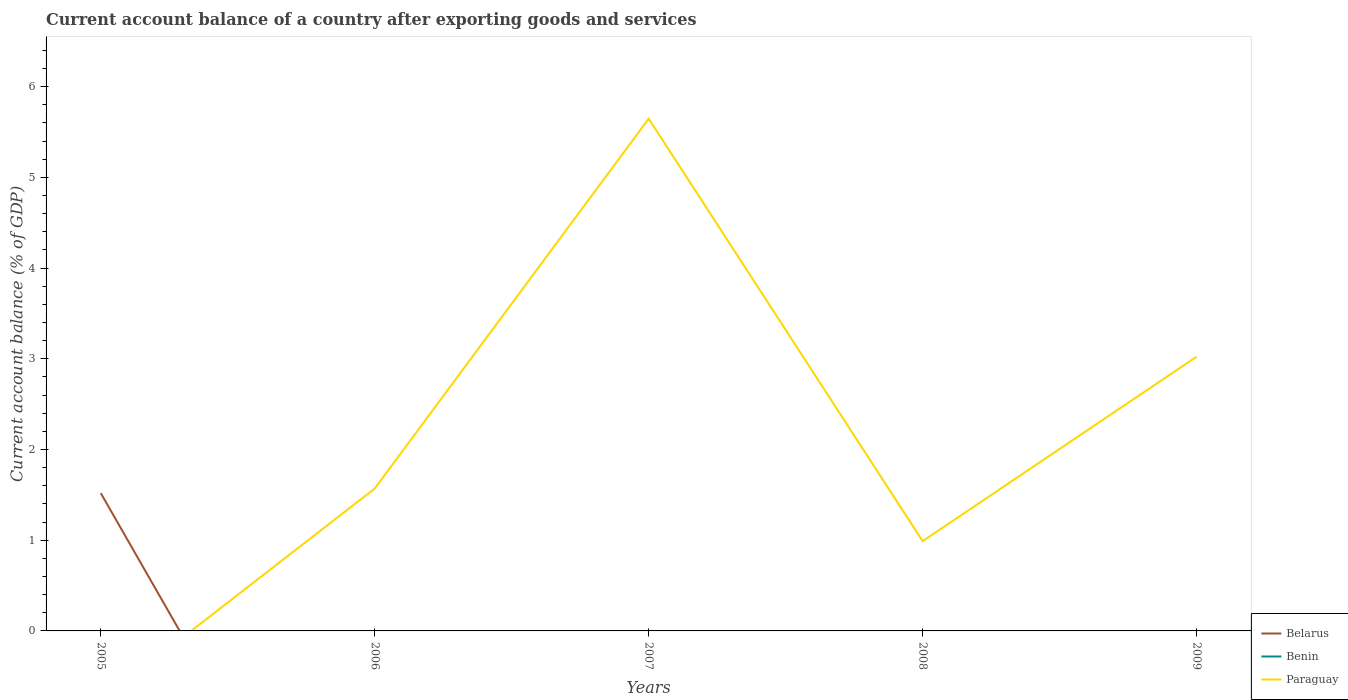How many different coloured lines are there?
Offer a terse response. 2. Is the number of lines equal to the number of legend labels?
Ensure brevity in your answer.  No. Across all years, what is the maximum account balance in Paraguay?
Provide a short and direct response. 0. What is the difference between the highest and the second highest account balance in Paraguay?
Give a very brief answer. 5.65. What is the difference between the highest and the lowest account balance in Benin?
Your response must be concise. 0. How many lines are there?
Your answer should be very brief. 2. Does the graph contain any zero values?
Ensure brevity in your answer.  Yes. Where does the legend appear in the graph?
Offer a terse response. Bottom right. How many legend labels are there?
Your response must be concise. 3. What is the title of the graph?
Your answer should be compact. Current account balance of a country after exporting goods and services. Does "Central African Republic" appear as one of the legend labels in the graph?
Give a very brief answer. No. What is the label or title of the Y-axis?
Your answer should be very brief. Current account balance (% of GDP). What is the Current account balance (% of GDP) of Belarus in 2005?
Give a very brief answer. 1.52. What is the Current account balance (% of GDP) in Paraguay in 2005?
Provide a succinct answer. 0. What is the Current account balance (% of GDP) of Benin in 2006?
Offer a terse response. 0. What is the Current account balance (% of GDP) in Paraguay in 2006?
Give a very brief answer. 1.57. What is the Current account balance (% of GDP) of Paraguay in 2007?
Your response must be concise. 5.65. What is the Current account balance (% of GDP) in Belarus in 2008?
Keep it short and to the point. 0. What is the Current account balance (% of GDP) in Paraguay in 2008?
Offer a very short reply. 0.99. What is the Current account balance (% of GDP) in Belarus in 2009?
Keep it short and to the point. 0. What is the Current account balance (% of GDP) of Benin in 2009?
Provide a short and direct response. 0. What is the Current account balance (% of GDP) in Paraguay in 2009?
Your answer should be compact. 3.02. Across all years, what is the maximum Current account balance (% of GDP) in Belarus?
Offer a terse response. 1.52. Across all years, what is the maximum Current account balance (% of GDP) in Paraguay?
Ensure brevity in your answer.  5.65. Across all years, what is the minimum Current account balance (% of GDP) of Paraguay?
Make the answer very short. 0. What is the total Current account balance (% of GDP) in Belarus in the graph?
Keep it short and to the point. 1.52. What is the total Current account balance (% of GDP) of Benin in the graph?
Give a very brief answer. 0. What is the total Current account balance (% of GDP) of Paraguay in the graph?
Provide a succinct answer. 11.23. What is the difference between the Current account balance (% of GDP) of Paraguay in 2006 and that in 2007?
Your answer should be very brief. -4.08. What is the difference between the Current account balance (% of GDP) in Paraguay in 2006 and that in 2008?
Your answer should be compact. 0.58. What is the difference between the Current account balance (% of GDP) in Paraguay in 2006 and that in 2009?
Make the answer very short. -1.45. What is the difference between the Current account balance (% of GDP) in Paraguay in 2007 and that in 2008?
Provide a succinct answer. 4.66. What is the difference between the Current account balance (% of GDP) in Paraguay in 2007 and that in 2009?
Offer a terse response. 2.62. What is the difference between the Current account balance (% of GDP) of Paraguay in 2008 and that in 2009?
Ensure brevity in your answer.  -2.03. What is the difference between the Current account balance (% of GDP) of Belarus in 2005 and the Current account balance (% of GDP) of Paraguay in 2006?
Offer a terse response. -0.05. What is the difference between the Current account balance (% of GDP) in Belarus in 2005 and the Current account balance (% of GDP) in Paraguay in 2007?
Offer a terse response. -4.13. What is the difference between the Current account balance (% of GDP) in Belarus in 2005 and the Current account balance (% of GDP) in Paraguay in 2008?
Give a very brief answer. 0.53. What is the difference between the Current account balance (% of GDP) in Belarus in 2005 and the Current account balance (% of GDP) in Paraguay in 2009?
Make the answer very short. -1.5. What is the average Current account balance (% of GDP) in Belarus per year?
Offer a very short reply. 0.3. What is the average Current account balance (% of GDP) of Paraguay per year?
Offer a very short reply. 2.25. What is the ratio of the Current account balance (% of GDP) of Paraguay in 2006 to that in 2007?
Offer a terse response. 0.28. What is the ratio of the Current account balance (% of GDP) of Paraguay in 2006 to that in 2008?
Keep it short and to the point. 1.59. What is the ratio of the Current account balance (% of GDP) in Paraguay in 2006 to that in 2009?
Your answer should be compact. 0.52. What is the ratio of the Current account balance (% of GDP) of Paraguay in 2007 to that in 2008?
Your answer should be very brief. 5.71. What is the ratio of the Current account balance (% of GDP) of Paraguay in 2007 to that in 2009?
Ensure brevity in your answer.  1.87. What is the ratio of the Current account balance (% of GDP) in Paraguay in 2008 to that in 2009?
Give a very brief answer. 0.33. What is the difference between the highest and the second highest Current account balance (% of GDP) in Paraguay?
Your answer should be very brief. 2.62. What is the difference between the highest and the lowest Current account balance (% of GDP) in Belarus?
Give a very brief answer. 1.52. What is the difference between the highest and the lowest Current account balance (% of GDP) in Paraguay?
Provide a succinct answer. 5.65. 